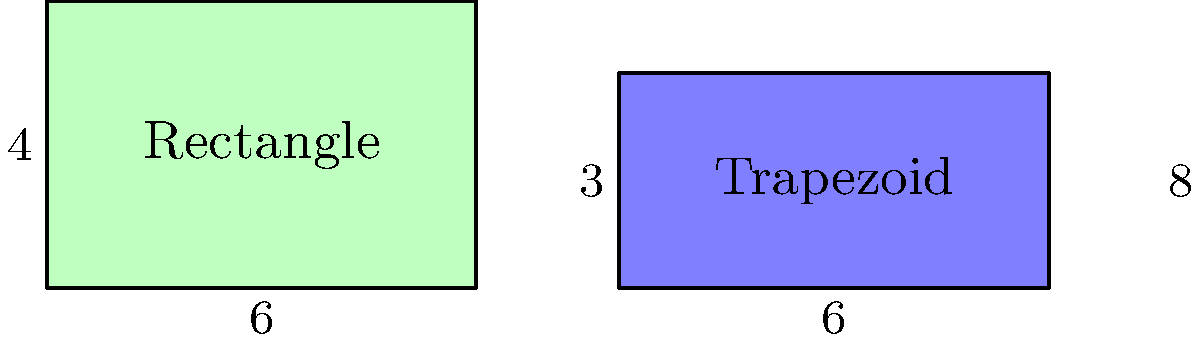The Meadow Lake City Council is considering two locations for a new community center. Location A is rectangular, while Location B is trapezoidal. The dimensions (in acres) are shown in the diagram. Which location offers more space for the community center, and by how many square acres? Let's calculate the areas of both locations:

1. Location A (Rectangle):
   Area = length × width
   $A_r = 6 \times 4 = 24$ square acres

2. Location B (Trapezoid):
   Area = $\frac{1}{2}(a+b)h$, where $a$ and $b$ are the parallel sides and $h$ is the height
   $A_t = \frac{1}{2}(6+8) \times 3 = \frac{1}{2} \times 14 \times 3 = 21$ square acres

3. Difference in area:
   $\Delta A = A_r - A_t = 24 - 21 = 3$ square acres

Therefore, Location A (Rectangle) offers more space for the community center by 3 square acres.
Answer: Location A, by 3 square acres 